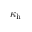<formula> <loc_0><loc_0><loc_500><loc_500>\kappa _ { h }</formula> 